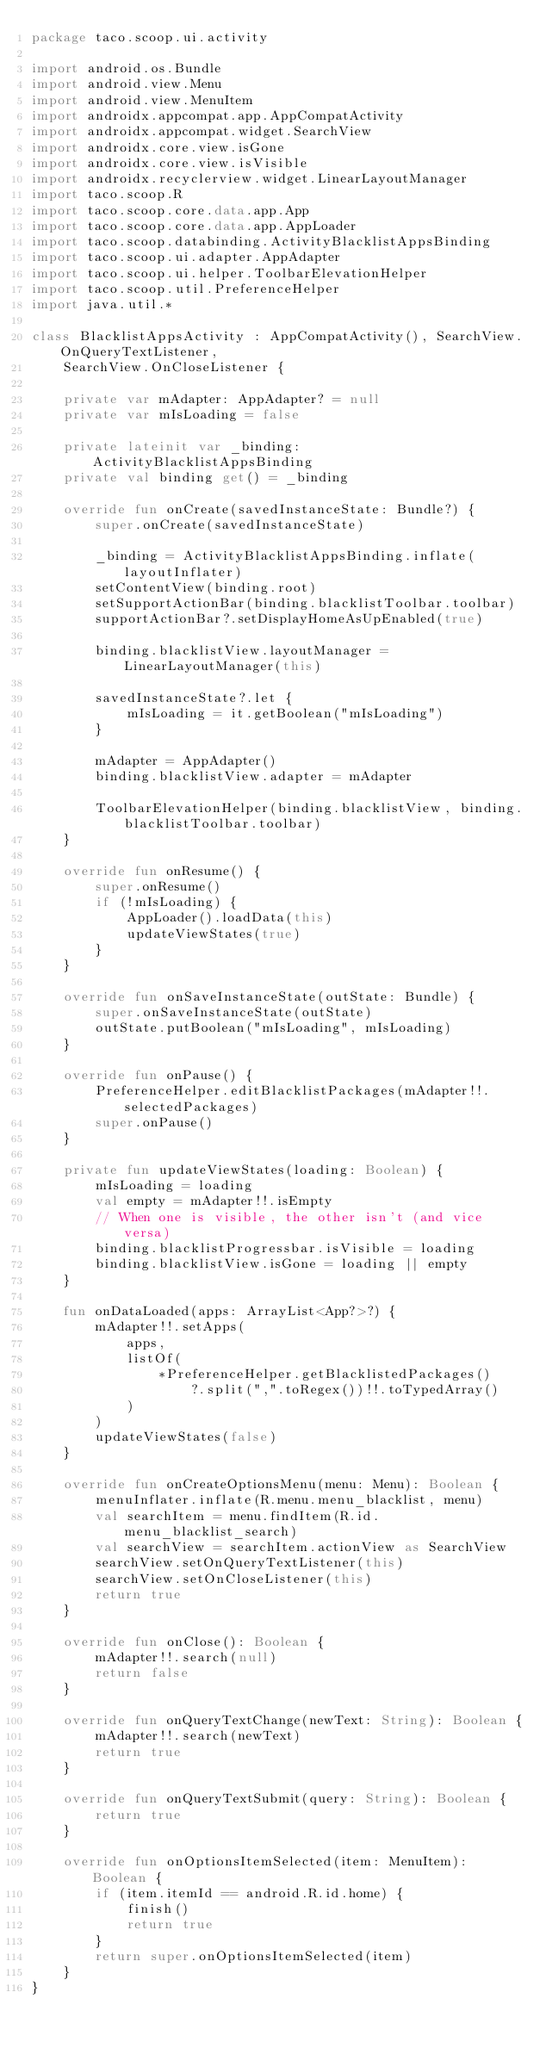<code> <loc_0><loc_0><loc_500><loc_500><_Kotlin_>package taco.scoop.ui.activity

import android.os.Bundle
import android.view.Menu
import android.view.MenuItem
import androidx.appcompat.app.AppCompatActivity
import androidx.appcompat.widget.SearchView
import androidx.core.view.isGone
import androidx.core.view.isVisible
import androidx.recyclerview.widget.LinearLayoutManager
import taco.scoop.R
import taco.scoop.core.data.app.App
import taco.scoop.core.data.app.AppLoader
import taco.scoop.databinding.ActivityBlacklistAppsBinding
import taco.scoop.ui.adapter.AppAdapter
import taco.scoop.ui.helper.ToolbarElevationHelper
import taco.scoop.util.PreferenceHelper
import java.util.*

class BlacklistAppsActivity : AppCompatActivity(), SearchView.OnQueryTextListener,
    SearchView.OnCloseListener {

    private var mAdapter: AppAdapter? = null
    private var mIsLoading = false

    private lateinit var _binding: ActivityBlacklistAppsBinding
    private val binding get() = _binding

    override fun onCreate(savedInstanceState: Bundle?) {
        super.onCreate(savedInstanceState)

        _binding = ActivityBlacklistAppsBinding.inflate(layoutInflater)
        setContentView(binding.root)
        setSupportActionBar(binding.blacklistToolbar.toolbar)
        supportActionBar?.setDisplayHomeAsUpEnabled(true)

        binding.blacklistView.layoutManager = LinearLayoutManager(this)

        savedInstanceState?.let {
            mIsLoading = it.getBoolean("mIsLoading")
        }

        mAdapter = AppAdapter()
        binding.blacklistView.adapter = mAdapter

        ToolbarElevationHelper(binding.blacklistView, binding.blacklistToolbar.toolbar)
    }

    override fun onResume() {
        super.onResume()
        if (!mIsLoading) {
            AppLoader().loadData(this)
            updateViewStates(true)
        }
    }

    override fun onSaveInstanceState(outState: Bundle) {
        super.onSaveInstanceState(outState)
        outState.putBoolean("mIsLoading", mIsLoading)
    }

    override fun onPause() {
        PreferenceHelper.editBlacklistPackages(mAdapter!!.selectedPackages)
        super.onPause()
    }

    private fun updateViewStates(loading: Boolean) {
        mIsLoading = loading
        val empty = mAdapter!!.isEmpty
        // When one is visible, the other isn't (and vice versa)
        binding.blacklistProgressbar.isVisible = loading
        binding.blacklistView.isGone = loading || empty
    }

    fun onDataLoaded(apps: ArrayList<App?>?) {
        mAdapter!!.setApps(
            apps,
            listOf(
                *PreferenceHelper.getBlacklistedPackages()
                    ?.split(",".toRegex())!!.toTypedArray()
            )
        )
        updateViewStates(false)
    }

    override fun onCreateOptionsMenu(menu: Menu): Boolean {
        menuInflater.inflate(R.menu.menu_blacklist, menu)
        val searchItem = menu.findItem(R.id.menu_blacklist_search)
        val searchView = searchItem.actionView as SearchView
        searchView.setOnQueryTextListener(this)
        searchView.setOnCloseListener(this)
        return true
    }

    override fun onClose(): Boolean {
        mAdapter!!.search(null)
        return false
    }

    override fun onQueryTextChange(newText: String): Boolean {
        mAdapter!!.search(newText)
        return true
    }

    override fun onQueryTextSubmit(query: String): Boolean {
        return true
    }

    override fun onOptionsItemSelected(item: MenuItem): Boolean {
        if (item.itemId == android.R.id.home) {
            finish()
            return true
        }
        return super.onOptionsItemSelected(item)
    }
}
</code> 